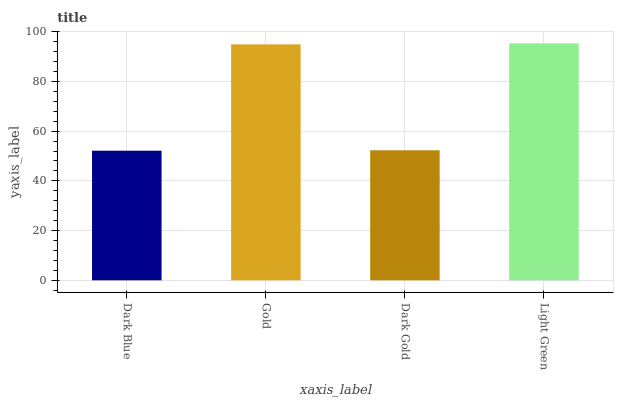Is Dark Blue the minimum?
Answer yes or no. Yes. Is Light Green the maximum?
Answer yes or no. Yes. Is Gold the minimum?
Answer yes or no. No. Is Gold the maximum?
Answer yes or no. No. Is Gold greater than Dark Blue?
Answer yes or no. Yes. Is Dark Blue less than Gold?
Answer yes or no. Yes. Is Dark Blue greater than Gold?
Answer yes or no. No. Is Gold less than Dark Blue?
Answer yes or no. No. Is Gold the high median?
Answer yes or no. Yes. Is Dark Gold the low median?
Answer yes or no. Yes. Is Light Green the high median?
Answer yes or no. No. Is Gold the low median?
Answer yes or no. No. 